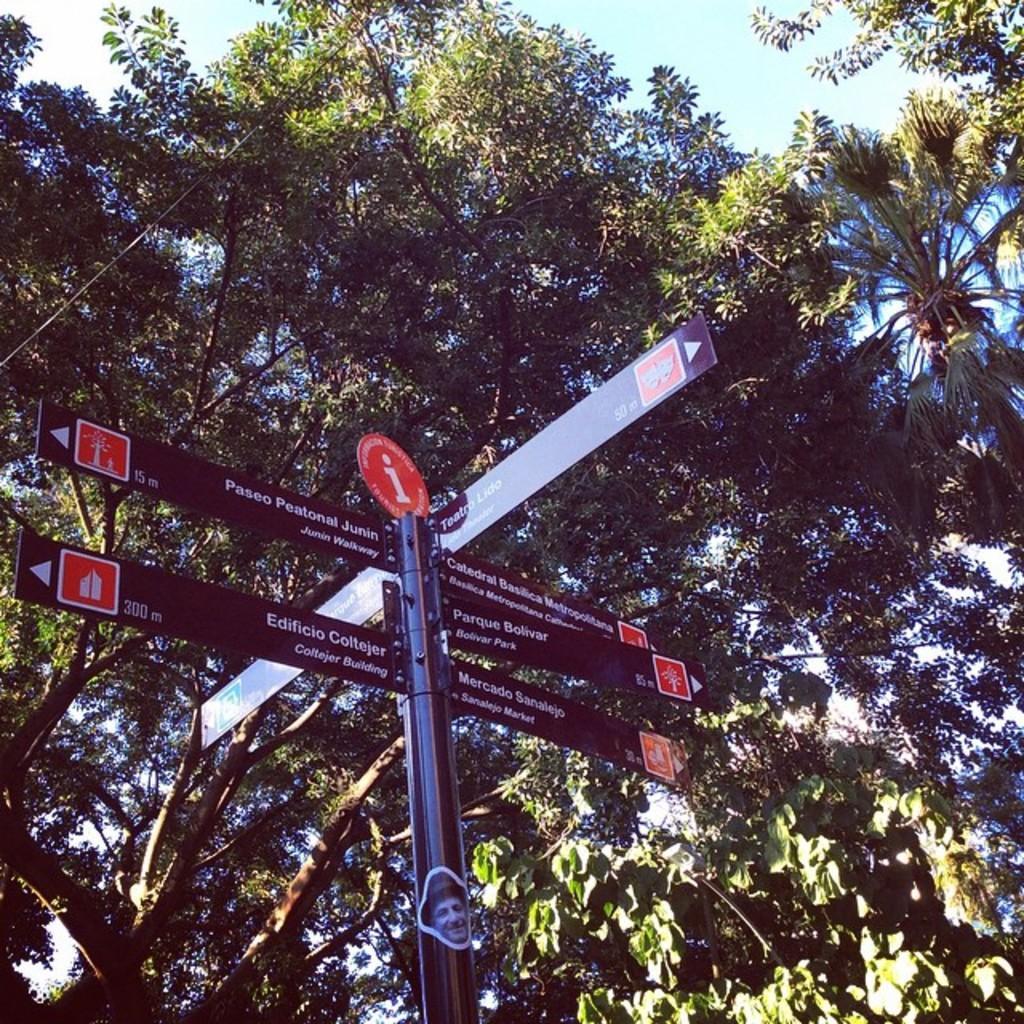How would you summarize this image in a sentence or two? In the foreground of this image, there is a sign board. In the background, there are trees and the sky. 